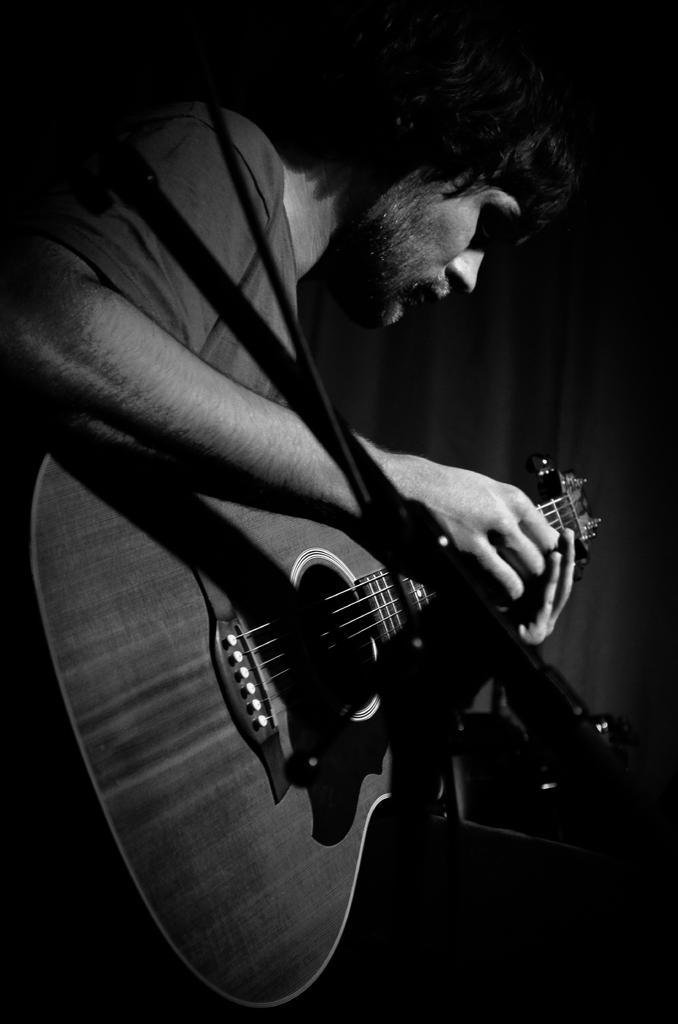Please provide a concise description of this image. In this image i can see a man playing a guitar. 